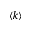Convert formula to latex. <formula><loc_0><loc_0><loc_500><loc_500>\langle k \rangle</formula> 